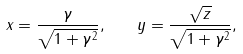Convert formula to latex. <formula><loc_0><loc_0><loc_500><loc_500>x = \frac { \gamma } { \sqrt { 1 + \gamma ^ { 2 } } } , \quad y = \frac { \sqrt { z } } { \sqrt { 1 + \gamma ^ { 2 } } } ,</formula> 